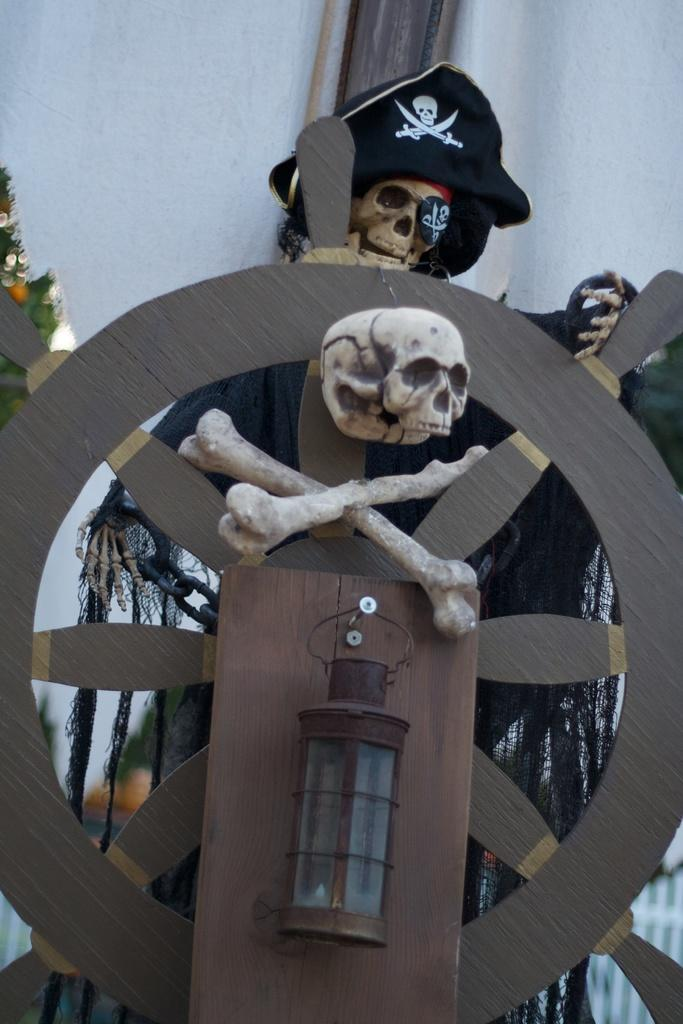What type of animal is in the image? There is a panther in the image. What other objects can be seen in the image? There are skulls, a ship wheel, a cap, and a chain in the image. What is visible in the background of the image? There is a wall in the background of the image. What letter does the panther write to its friend in the image? There is no letter or writing activity present in the image. 